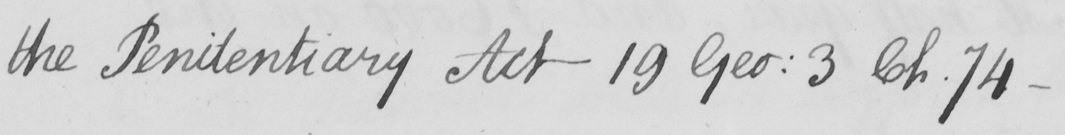What does this handwritten line say? the Penitentiary Act 19 Geo :  3 Ch . 74- 